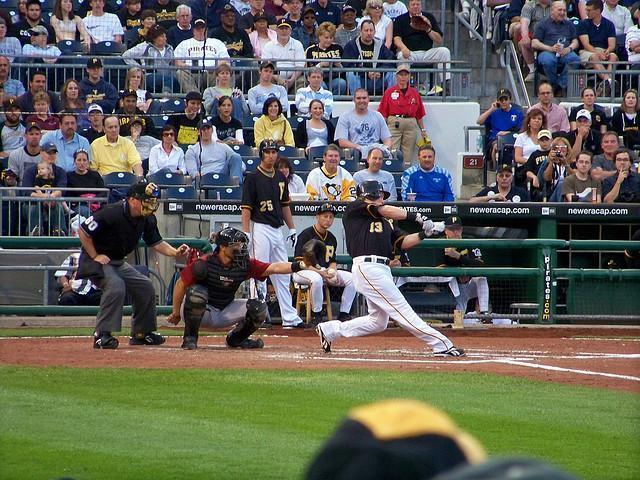Which former teammate of Chipper Jones is standing in the on-deck circle?
Choose the correct response and explain in the format: 'Answer: answer
Rationale: rationale.'
Options: Otis nixon, david wright, adam laroche, mike trout. Answer: adam laroche.
Rationale: The number shown is that athletes number. 